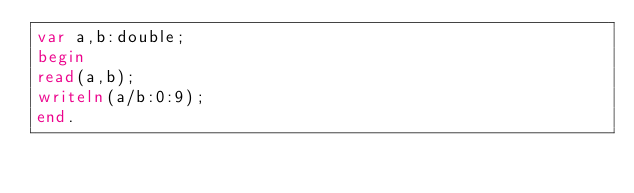Convert code to text. <code><loc_0><loc_0><loc_500><loc_500><_Pascal_>var a,b:double;
begin
read(a,b);
writeln(a/b:0:9);
end.</code> 